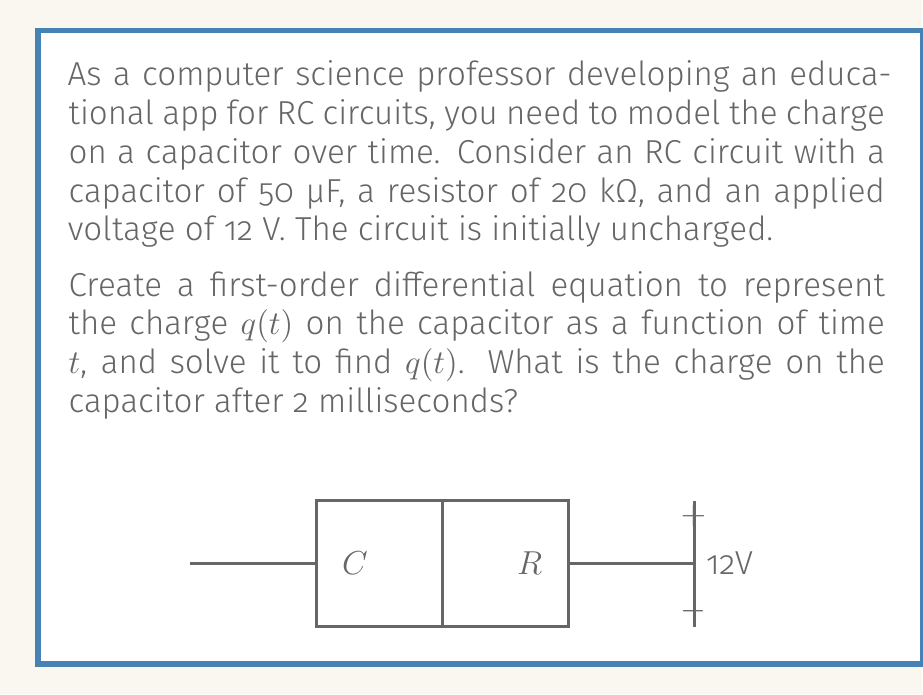Solve this math problem. Let's approach this step-by-step:

1) The differential equation for an RC circuit is:

   $$R\frac{dq}{dt} + \frac{q}{C} = V$$

   where $R$ is resistance, $C$ is capacitance, $q$ is charge, and $V$ is voltage.

2) Substituting the given values:

   $$20000\frac{dq}{dt} + \frac{q}{50 \times 10^{-6}} = 12$$

3) Simplify:

   $$20000\frac{dq}{dt} + 20000q = 12$$

4) This is a first-order linear differential equation. The general solution is:

   $$q(t) = Ae^{-t/RC} + CV$$

   where $A$ is a constant determined by initial conditions.

5) Given $R = 20000$ Ω and $C = 50 \times 10^{-6}$ F:

   $$q(t) = Ae^{-t/(20000 \times 50 \times 10^{-6})} + 50 \times 10^{-6} \times 12$$

6) Simplify:

   $$q(t) = Ae^{-1000t} + 600 \times 10^{-6}$$

7) At $t = 0$, $q = 0$ (initially uncharged). So:

   $$0 = A + 600 \times 10^{-6}$$
   $$A = -600 \times 10^{-6}$$

8) Therefore, the final equation is:

   $$q(t) = 600 \times 10^{-6}(1 - e^{-1000t})$$

9) To find the charge after 2 milliseconds, substitute $t = 0.002$:

   $$q(0.002) = 600 \times 10^{-6}(1 - e^{-1000 \times 0.002})$$
   $$= 600 \times 10^{-6}(1 - e^{-2})$$
   $$\approx 5.22 \times 10^{-7}$$ C
Answer: $5.22 \times 10^{-7}$ C 